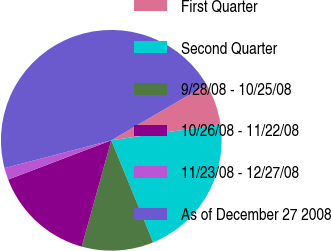<chart> <loc_0><loc_0><loc_500><loc_500><pie_chart><fcel>First Quarter<fcel>Second Quarter<fcel>9/28/08 - 10/25/08<fcel>10/26/08 - 11/22/08<fcel>11/23/08 - 12/27/08<fcel>As of December 27 2008<nl><fcel>6.12%<fcel>21.09%<fcel>10.51%<fcel>14.9%<fcel>1.73%<fcel>45.65%<nl></chart> 